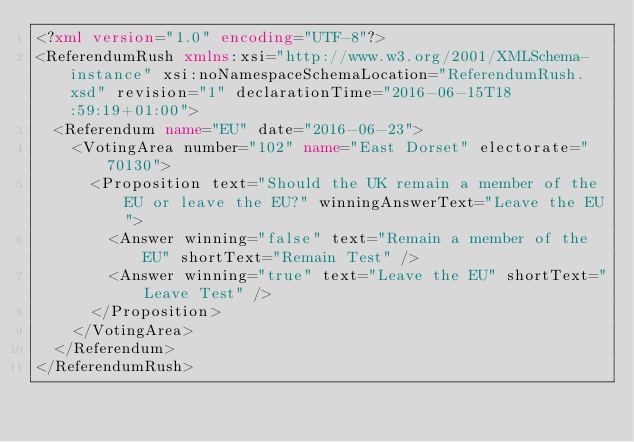Convert code to text. <code><loc_0><loc_0><loc_500><loc_500><_XML_><?xml version="1.0" encoding="UTF-8"?>
<ReferendumRush xmlns:xsi="http://www.w3.org/2001/XMLSchema-instance" xsi:noNamespaceSchemaLocation="ReferendumRush.xsd" revision="1" declarationTime="2016-06-15T18:59:19+01:00">
  <Referendum name="EU" date="2016-06-23">
    <VotingArea number="102" name="East Dorset" electorate="70130">
      <Proposition text="Should the UK remain a member of the EU or leave the EU?" winningAnswerText="Leave the EU">
        <Answer winning="false" text="Remain a member of the EU" shortText="Remain Test" />
        <Answer winning="true" text="Leave the EU" shortText="Leave Test" />
      </Proposition>
    </VotingArea>
  </Referendum>
</ReferendumRush>

</code> 